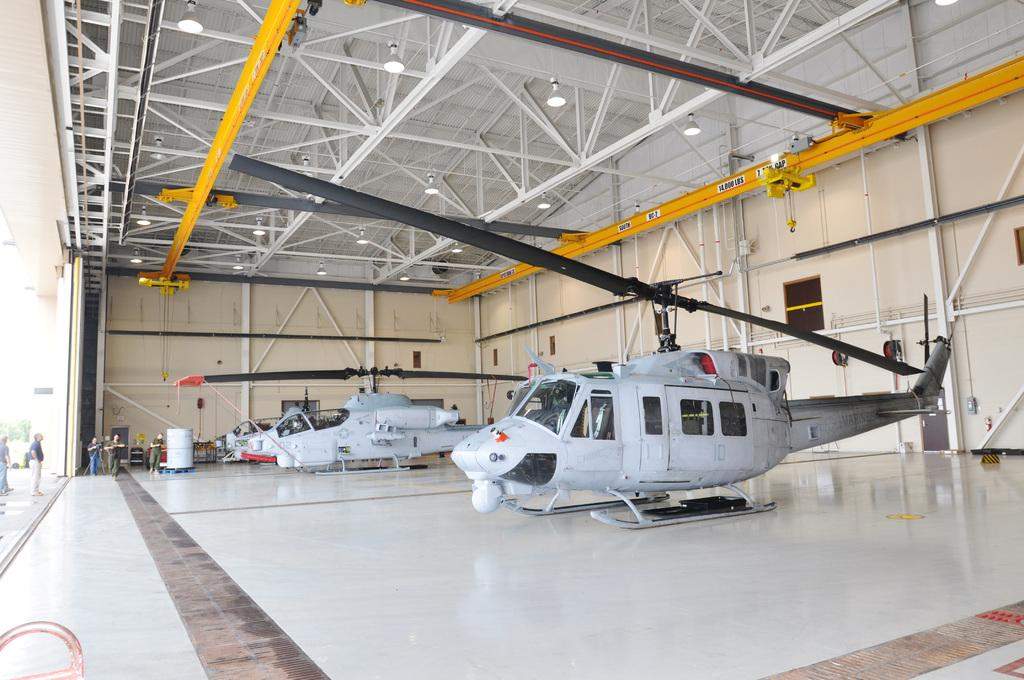What is the main subject of the image? The main subject of the image is aircrafts. What else can be seen in the image besides the aircrafts? There is a building and people standing in the image. Are there any objects on the floor in the image? Yes, there are objects on the floor in the image. How many cakes are on the roof of the building in the image? There are no cakes present in the image, and the roof of the building is not visible. 